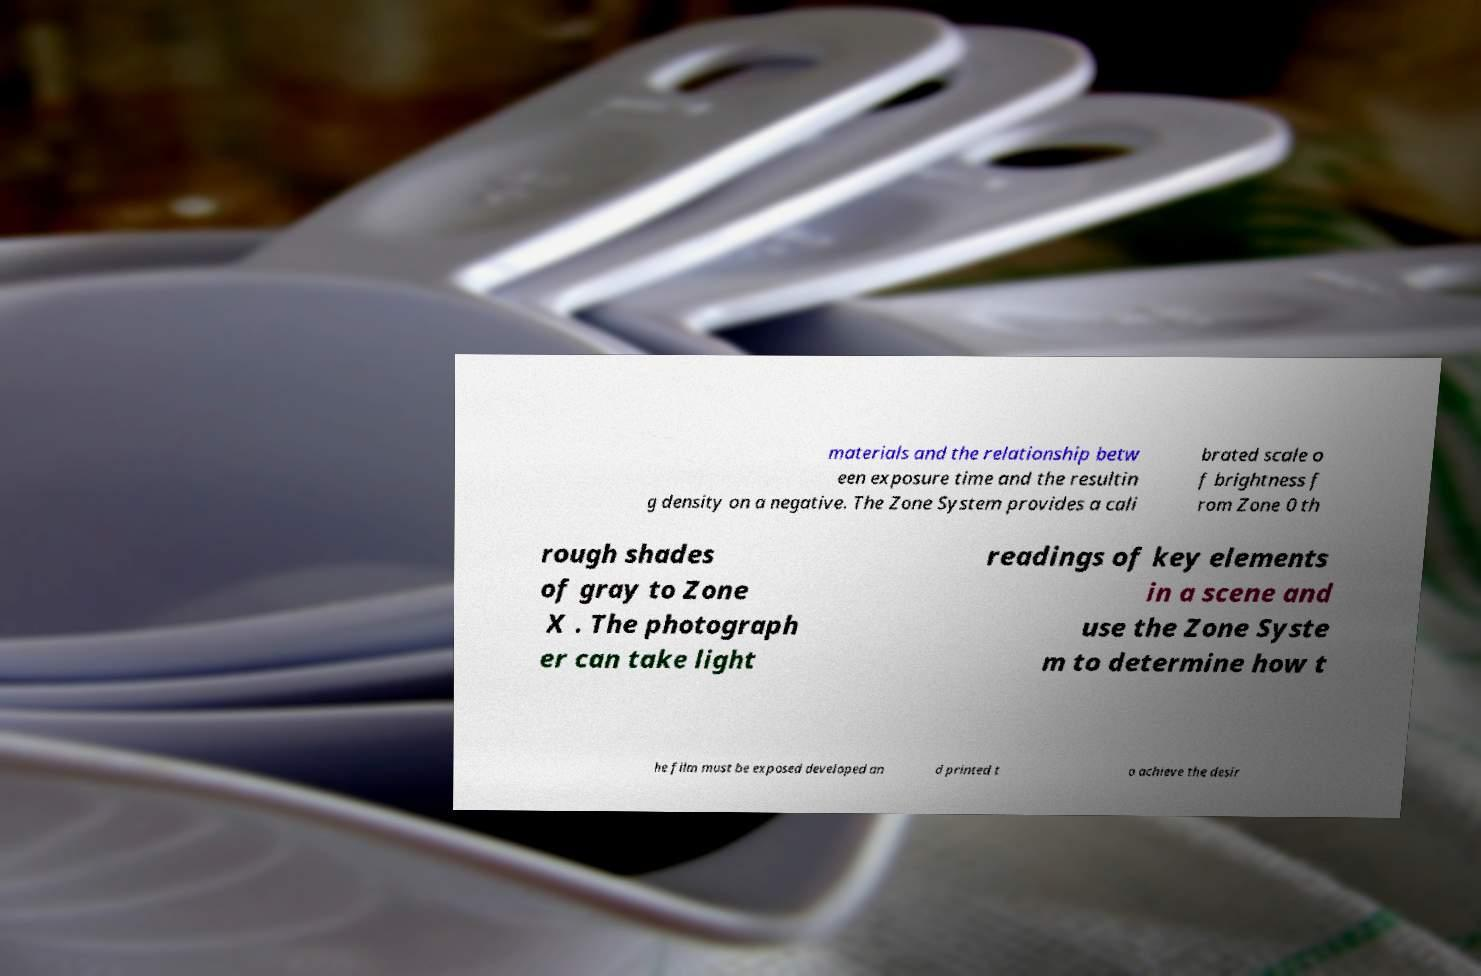I need the written content from this picture converted into text. Can you do that? materials and the relationship betw een exposure time and the resultin g density on a negative. The Zone System provides a cali brated scale o f brightness f rom Zone 0 th rough shades of gray to Zone X . The photograph er can take light readings of key elements in a scene and use the Zone Syste m to determine how t he film must be exposed developed an d printed t o achieve the desir 